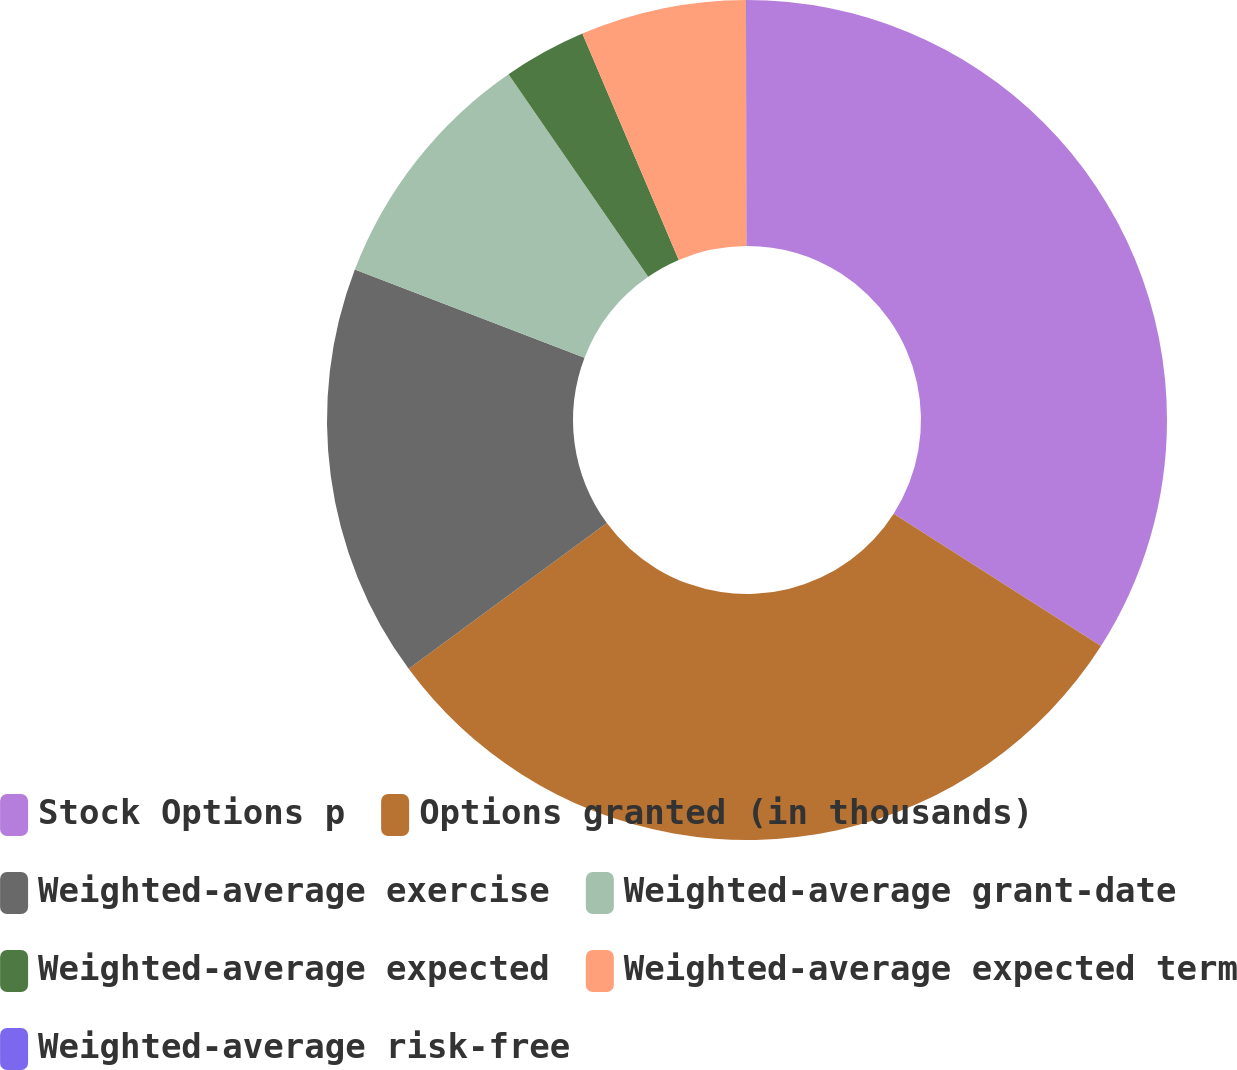<chart> <loc_0><loc_0><loc_500><loc_500><pie_chart><fcel>Stock Options p<fcel>Options granted (in thousands)<fcel>Weighted-average exercise<fcel>Weighted-average grant-date<fcel>Weighted-average expected<fcel>Weighted-average expected term<fcel>Weighted-average risk-free<nl><fcel>34.04%<fcel>30.86%<fcel>15.92%<fcel>9.56%<fcel>3.2%<fcel>6.38%<fcel>0.03%<nl></chart> 